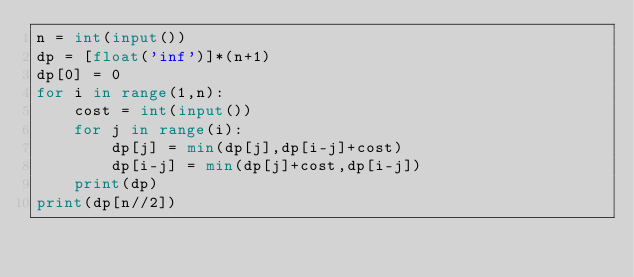<code> <loc_0><loc_0><loc_500><loc_500><_Python_>n = int(input())
dp = [float('inf')]*(n+1)
dp[0] = 0
for i in range(1,n):
    cost = int(input())
    for j in range(i):
        dp[j] = min(dp[j],dp[i-j]+cost)
        dp[i-j] = min(dp[j]+cost,dp[i-j])
    print(dp)
print(dp[n//2])</code> 